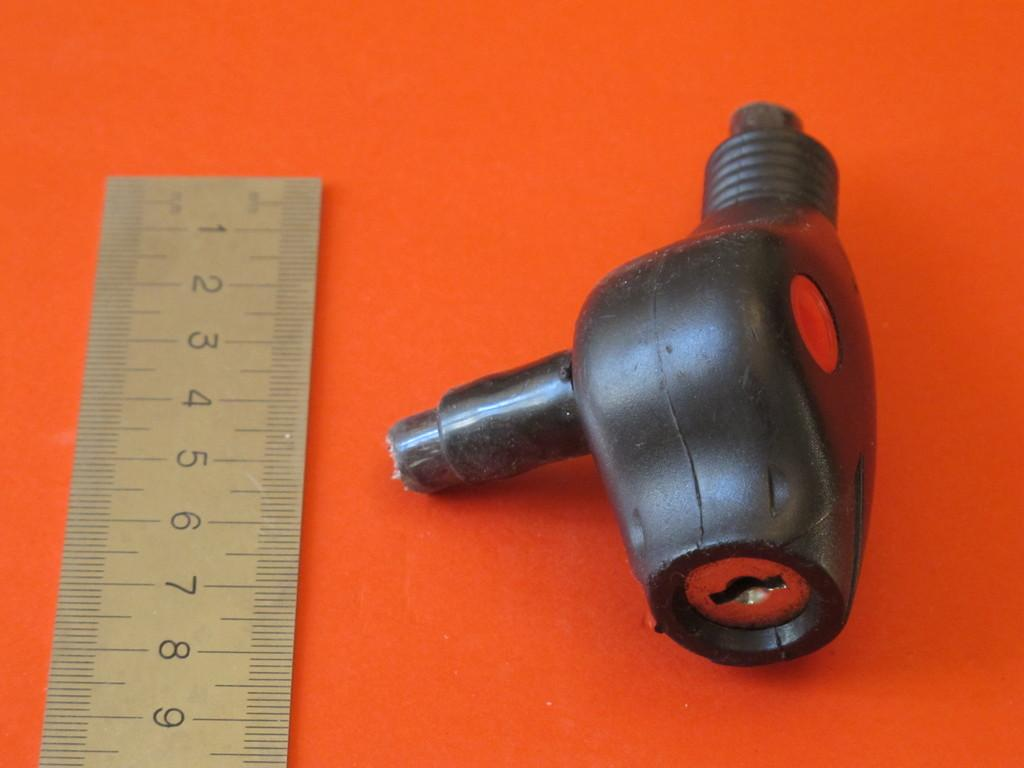<image>
Summarize the visual content of the image. A key lock is being measured in front of the numbers 1-9 on a ruler 